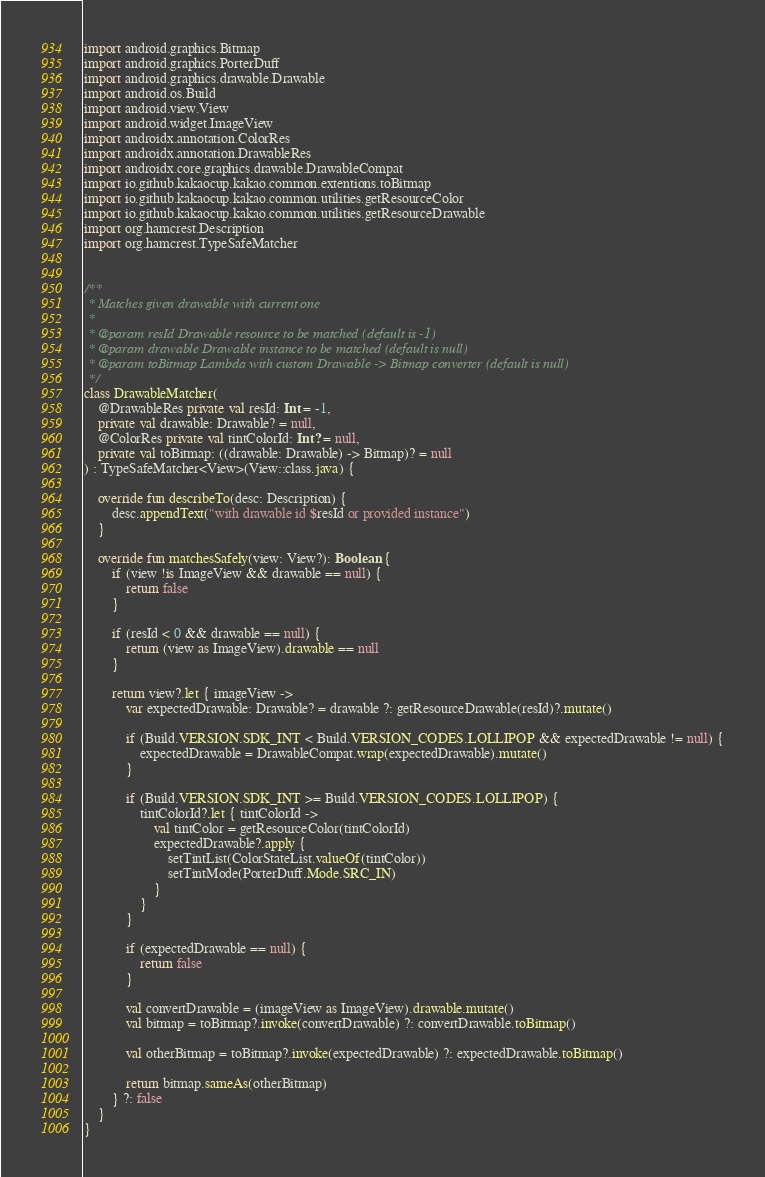Convert code to text. <code><loc_0><loc_0><loc_500><loc_500><_Kotlin_>import android.graphics.Bitmap
import android.graphics.PorterDuff
import android.graphics.drawable.Drawable
import android.os.Build
import android.view.View
import android.widget.ImageView
import androidx.annotation.ColorRes
import androidx.annotation.DrawableRes
import androidx.core.graphics.drawable.DrawableCompat
import io.github.kakaocup.kakao.common.extentions.toBitmap
import io.github.kakaocup.kakao.common.utilities.getResourceColor
import io.github.kakaocup.kakao.common.utilities.getResourceDrawable
import org.hamcrest.Description
import org.hamcrest.TypeSafeMatcher


/**
 * Matches given drawable with current one
 *
 * @param resId Drawable resource to be matched (default is -1)
 * @param drawable Drawable instance to be matched (default is null)
 * @param toBitmap Lambda with custom Drawable -> Bitmap converter (default is null)
 */
class DrawableMatcher(
    @DrawableRes private val resId: Int = -1,
    private val drawable: Drawable? = null,
    @ColorRes private val tintColorId: Int? = null,
    private val toBitmap: ((drawable: Drawable) -> Bitmap)? = null
) : TypeSafeMatcher<View>(View::class.java) {

    override fun describeTo(desc: Description) {
        desc.appendText("with drawable id $resId or provided instance")
    }

    override fun matchesSafely(view: View?): Boolean {
        if (view !is ImageView && drawable == null) {
            return false
        }

        if (resId < 0 && drawable == null) {
            return (view as ImageView).drawable == null
        }

        return view?.let { imageView ->
            var expectedDrawable: Drawable? = drawable ?: getResourceDrawable(resId)?.mutate()

            if (Build.VERSION.SDK_INT < Build.VERSION_CODES.LOLLIPOP && expectedDrawable != null) {
                expectedDrawable = DrawableCompat.wrap(expectedDrawable).mutate()
            }

            if (Build.VERSION.SDK_INT >= Build.VERSION_CODES.LOLLIPOP) {
                tintColorId?.let { tintColorId ->
                    val tintColor = getResourceColor(tintColorId)
                    expectedDrawable?.apply {
                        setTintList(ColorStateList.valueOf(tintColor))
                        setTintMode(PorterDuff.Mode.SRC_IN)
                    }
                }
            }

            if (expectedDrawable == null) {
                return false
            }

            val convertDrawable = (imageView as ImageView).drawable.mutate()
            val bitmap = toBitmap?.invoke(convertDrawable) ?: convertDrawable.toBitmap()

            val otherBitmap = toBitmap?.invoke(expectedDrawable) ?: expectedDrawable.toBitmap()

            return bitmap.sameAs(otherBitmap)
        } ?: false
    }
}
</code> 